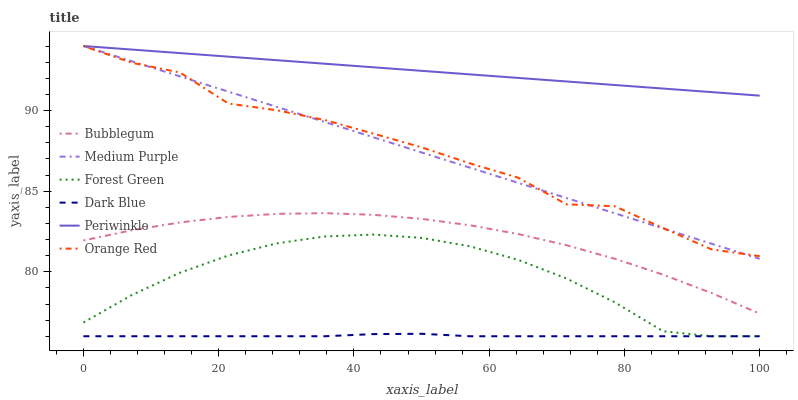Does Dark Blue have the minimum area under the curve?
Answer yes or no. Yes. Does Periwinkle have the maximum area under the curve?
Answer yes or no. Yes. Does Medium Purple have the minimum area under the curve?
Answer yes or no. No. Does Medium Purple have the maximum area under the curve?
Answer yes or no. No. Is Periwinkle the smoothest?
Answer yes or no. Yes. Is Orange Red the roughest?
Answer yes or no. Yes. Is Medium Purple the smoothest?
Answer yes or no. No. Is Medium Purple the roughest?
Answer yes or no. No. Does Dark Blue have the lowest value?
Answer yes or no. Yes. Does Medium Purple have the lowest value?
Answer yes or no. No. Does Orange Red have the highest value?
Answer yes or no. Yes. Does Dark Blue have the highest value?
Answer yes or no. No. Is Bubblegum less than Periwinkle?
Answer yes or no. Yes. Is Orange Red greater than Bubblegum?
Answer yes or no. Yes. Does Orange Red intersect Periwinkle?
Answer yes or no. Yes. Is Orange Red less than Periwinkle?
Answer yes or no. No. Is Orange Red greater than Periwinkle?
Answer yes or no. No. Does Bubblegum intersect Periwinkle?
Answer yes or no. No. 